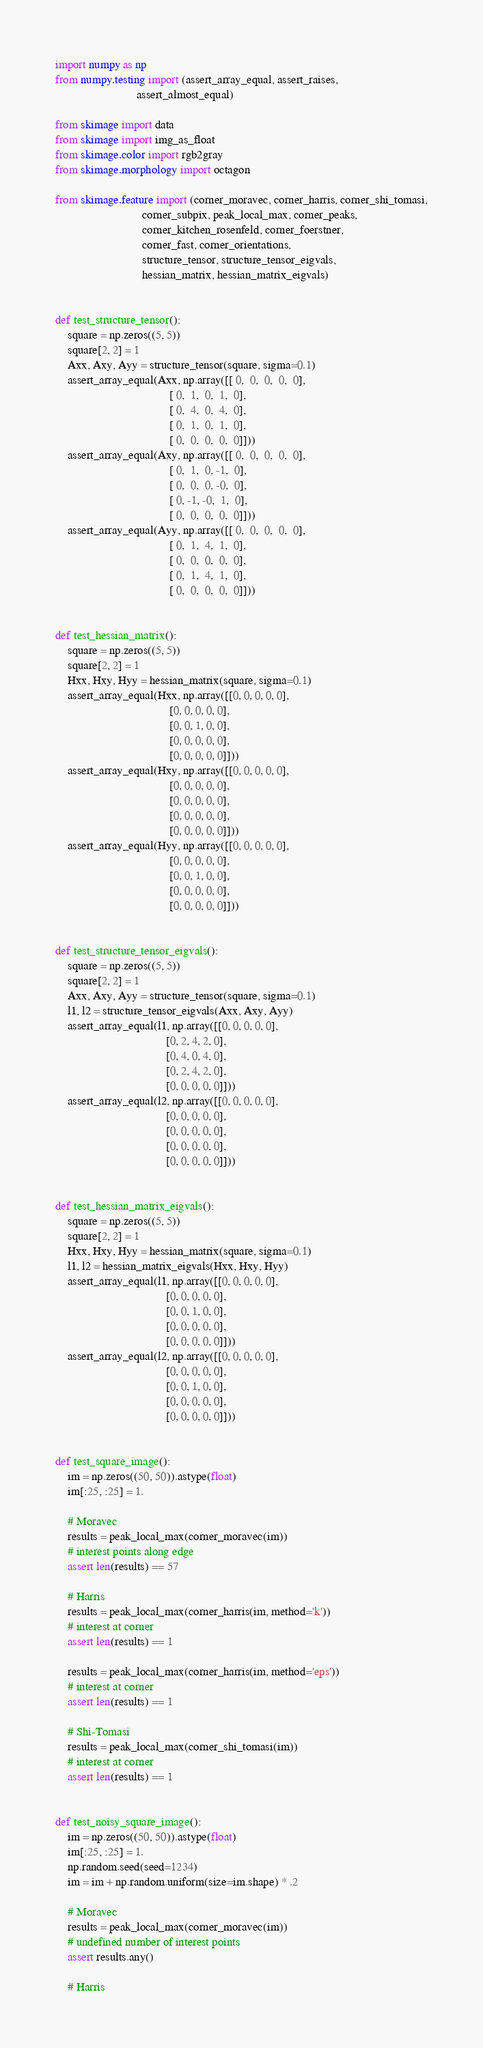Convert code to text. <code><loc_0><loc_0><loc_500><loc_500><_Python_>import numpy as np
from numpy.testing import (assert_array_equal, assert_raises,
                           assert_almost_equal)

from skimage import data
from skimage import img_as_float
from skimage.color import rgb2gray
from skimage.morphology import octagon

from skimage.feature import (corner_moravec, corner_harris, corner_shi_tomasi,
                             corner_subpix, peak_local_max, corner_peaks,
                             corner_kitchen_rosenfeld, corner_foerstner,
                             corner_fast, corner_orientations,
                             structure_tensor, structure_tensor_eigvals,
                             hessian_matrix, hessian_matrix_eigvals)


def test_structure_tensor():
    square = np.zeros((5, 5))
    square[2, 2] = 1
    Axx, Axy, Ayy = structure_tensor(square, sigma=0.1)
    assert_array_equal(Axx, np.array([[ 0,  0,  0,  0,  0],
                                      [ 0,  1,  0,  1,  0],
                                      [ 0,  4,  0,  4,  0],
                                      [ 0,  1,  0,  1,  0],
                                      [ 0,  0,  0,  0,  0]]))
    assert_array_equal(Axy, np.array([[ 0,  0,  0,  0,  0],
                                      [ 0,  1,  0, -1,  0],
                                      [ 0,  0,  0, -0,  0],
                                      [ 0, -1, -0,  1,  0],
                                      [ 0,  0,  0,  0,  0]]))
    assert_array_equal(Ayy, np.array([[ 0,  0,  0,  0,  0],
                                      [ 0,  1,  4,  1,  0],
                                      [ 0,  0,  0,  0,  0],
                                      [ 0,  1,  4,  1,  0],
                                      [ 0,  0,  0,  0,  0]]))


def test_hessian_matrix():
    square = np.zeros((5, 5))
    square[2, 2] = 1
    Hxx, Hxy, Hyy = hessian_matrix(square, sigma=0.1)
    assert_array_equal(Hxx, np.array([[0, 0, 0, 0, 0],
                                      [0, 0, 0, 0, 0],
                                      [0, 0, 1, 0, 0],
                                      [0, 0, 0, 0, 0],
                                      [0, 0, 0, 0, 0]]))
    assert_array_equal(Hxy, np.array([[0, 0, 0, 0, 0],
                                      [0, 0, 0, 0, 0],
                                      [0, 0, 0, 0, 0],
                                      [0, 0, 0, 0, 0],
                                      [0, 0, 0, 0, 0]]))
    assert_array_equal(Hyy, np.array([[0, 0, 0, 0, 0],
                                      [0, 0, 0, 0, 0],
                                      [0, 0, 1, 0, 0],
                                      [0, 0, 0, 0, 0],
                                      [0, 0, 0, 0, 0]]))


def test_structure_tensor_eigvals():
    square = np.zeros((5, 5))
    square[2, 2] = 1
    Axx, Axy, Ayy = structure_tensor(square, sigma=0.1)
    l1, l2 = structure_tensor_eigvals(Axx, Axy, Ayy)
    assert_array_equal(l1, np.array([[0, 0, 0, 0, 0],
                                     [0, 2, 4, 2, 0],
                                     [0, 4, 0, 4, 0],
                                     [0, 2, 4, 2, 0],
                                     [0, 0, 0, 0, 0]]))
    assert_array_equal(l2, np.array([[0, 0, 0, 0, 0],
                                     [0, 0, 0, 0, 0],
                                     [0, 0, 0, 0, 0],
                                     [0, 0, 0, 0, 0],
                                     [0, 0, 0, 0, 0]]))


def test_hessian_matrix_eigvals():
    square = np.zeros((5, 5))
    square[2, 2] = 1
    Hxx, Hxy, Hyy = hessian_matrix(square, sigma=0.1)
    l1, l2 = hessian_matrix_eigvals(Hxx, Hxy, Hyy)
    assert_array_equal(l1, np.array([[0, 0, 0, 0, 0],
                                     [0, 0, 0, 0, 0],
                                     [0, 0, 1, 0, 0],
                                     [0, 0, 0, 0, 0],
                                     [0, 0, 0, 0, 0]]))
    assert_array_equal(l2, np.array([[0, 0, 0, 0, 0],
                                     [0, 0, 0, 0, 0],
                                     [0, 0, 1, 0, 0],
                                     [0, 0, 0, 0, 0],
                                     [0, 0, 0, 0, 0]]))


def test_square_image():
    im = np.zeros((50, 50)).astype(float)
    im[:25, :25] = 1.

    # Moravec
    results = peak_local_max(corner_moravec(im))
    # interest points along edge
    assert len(results) == 57

    # Harris
    results = peak_local_max(corner_harris(im, method='k'))
    # interest at corner
    assert len(results) == 1

    results = peak_local_max(corner_harris(im, method='eps'))
    # interest at corner
    assert len(results) == 1

    # Shi-Tomasi
    results = peak_local_max(corner_shi_tomasi(im))
    # interest at corner
    assert len(results) == 1


def test_noisy_square_image():
    im = np.zeros((50, 50)).astype(float)
    im[:25, :25] = 1.
    np.random.seed(seed=1234)
    im = im + np.random.uniform(size=im.shape) * .2

    # Moravec
    results = peak_local_max(corner_moravec(im))
    # undefined number of interest points
    assert results.any()

    # Harris</code> 